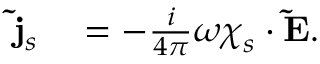Convert formula to latex. <formula><loc_0><loc_0><loc_500><loc_500>\begin{array} { r l } { \tilde { j } _ { s } } & = - \frac { i } { 4 \pi } \omega \chi _ { s } \cdot \tilde { E } . } \end{array}</formula> 